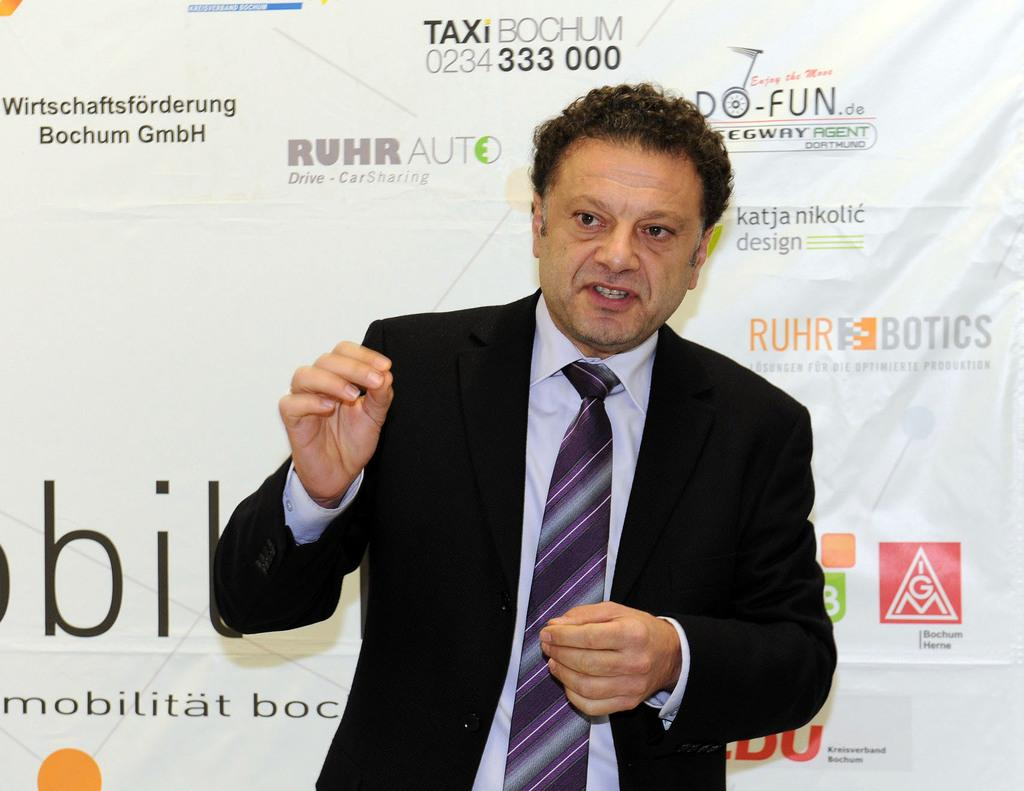Who is in the image? There is a person in the image. What is the person wearing? The person is wearing a black suit. What is the person doing in the image? The person is standing and speaking. What can be seen in the background of the image? There is a white banner in the background of the image. What is written on the banner? Texts are printed on the banner. How many jellyfish are swimming in the background of the image? There are no jellyfish present in the image; it features a person wearing a black suit and a white banner in the background. What type of knife is being used by the person in the image? There is no knife visible in the image; the person is standing and speaking while wearing a black suit. 